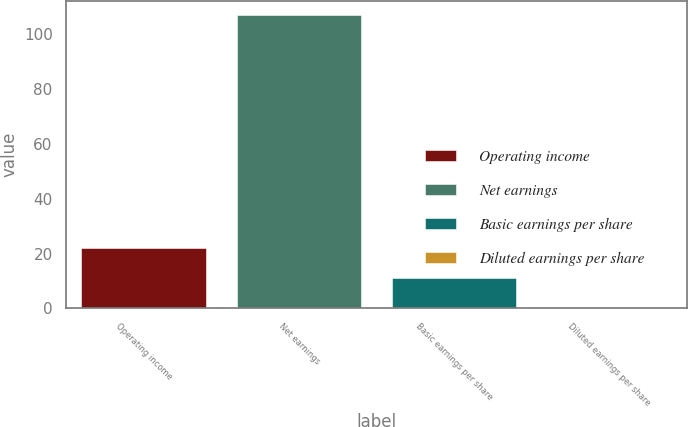<chart> <loc_0><loc_0><loc_500><loc_500><bar_chart><fcel>Operating income<fcel>Net earnings<fcel>Basic earnings per share<fcel>Diluted earnings per share<nl><fcel>21.89<fcel>107<fcel>11.25<fcel>0.61<nl></chart> 